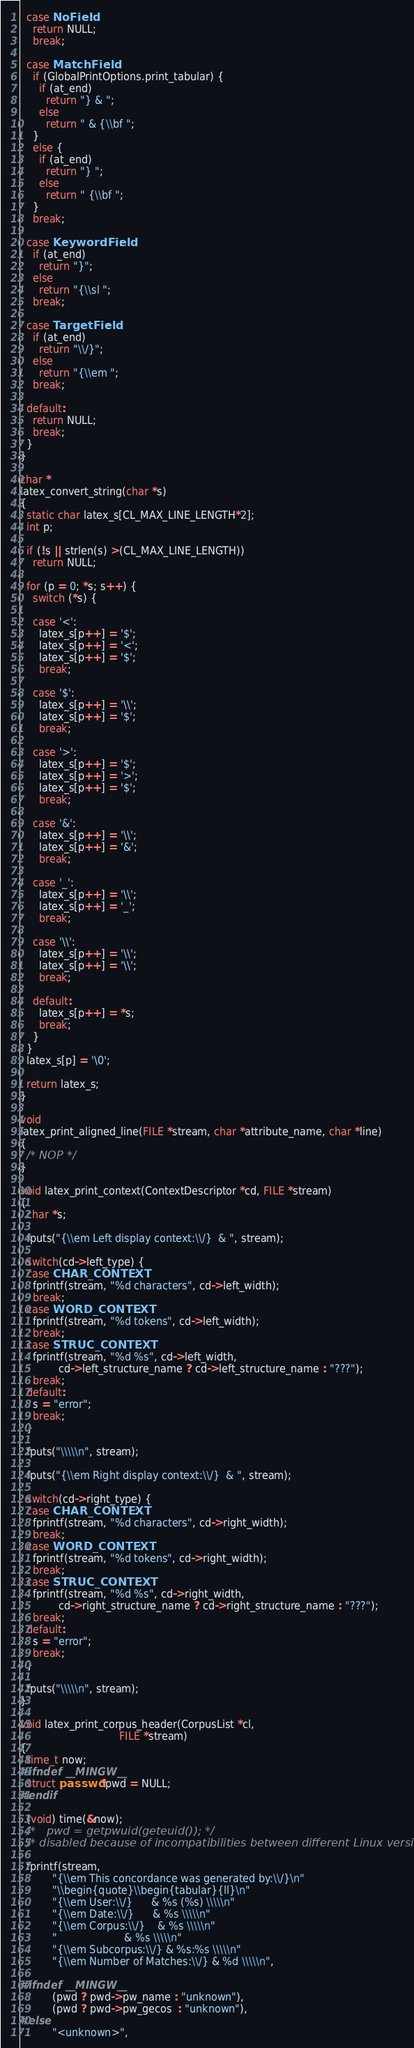<code> <loc_0><loc_0><loc_500><loc_500><_C_>
  case NoField:
    return NULL;
    break;

  case MatchField:
    if (GlobalPrintOptions.print_tabular) {
      if (at_end)
        return "} & ";
      else
        return " & {\\bf ";
    }
    else {
      if (at_end)
        return "} ";
      else
        return " {\\bf ";
    }
    break;

  case KeywordField:
    if (at_end)
      return "}";
    else
      return "{\\sl ";
    break;

  case TargetField:
    if (at_end)
      return "\\/}";
    else
      return "{\\em ";
    break;

  default:
    return NULL;
    break;
  }
}

char *
latex_convert_string(char *s)
{
  static char latex_s[CL_MAX_LINE_LENGTH*2];
  int p;

  if (!s || strlen(s) >(CL_MAX_LINE_LENGTH))
    return NULL;
  
  for (p = 0; *s; s++) {
    switch (*s) {

    case '<':
      latex_s[p++] = '$';
      latex_s[p++] = '<';
      latex_s[p++] = '$';
      break;

    case '$':
      latex_s[p++] = '\\';
      latex_s[p++] = '$';
      break;

    case '>':
      latex_s[p++] = '$';
      latex_s[p++] = '>';
      latex_s[p++] = '$';
      break;

    case '&':
      latex_s[p++] = '\\';
      latex_s[p++] = '&';
      break;

    case '_':
      latex_s[p++] = '\\';
      latex_s[p++] = '_';
      break;

    case '\\':
      latex_s[p++] = '\\';
      latex_s[p++] = '\\';
      break;

    default:
      latex_s[p++] = *s;
      break;
    }
  }
  latex_s[p] = '\0';

  return latex_s;
}

void
latex_print_aligned_line(FILE *stream, char *attribute_name, char *line)
{
  /* NOP */
}

void latex_print_context(ContextDescriptor *cd, FILE *stream)
{
  char *s;

  fputs("{\\em Left display context:\\/}  & ", stream);

  switch(cd->left_type) {
  case CHAR_CONTEXT:
    fprintf(stream, "%d characters", cd->left_width);
    break;
  case WORD_CONTEXT:
    fprintf(stream, "%d tokens", cd->left_width);
    break;
  case STRUC_CONTEXT:
    fprintf(stream, "%d %s", cd->left_width, 
            cd->left_structure_name ? cd->left_structure_name : "???");
    break;
  default:
    s = "error";
    break;
  }

  fputs("\\\\\n", stream);

  fputs("{\\em Right display context:\\/}  & ", stream);

  switch(cd->right_type) {
  case CHAR_CONTEXT:
    fprintf(stream, "%d characters", cd->right_width);
    break;
  case WORD_CONTEXT:
    fprintf(stream, "%d tokens", cd->right_width);
    break;
  case STRUC_CONTEXT:
    fprintf(stream, "%d %s", cd->right_width, 
            cd->right_structure_name ? cd->right_structure_name : "???");
    break;
  default:
    s = "error";
    break;
  }

  fputs("\\\\\n", stream);
}

void latex_print_corpus_header(CorpusList *cl, 
                               FILE *stream)
{
  time_t now;
#ifndef __MINGW__
  struct passwd *pwd = NULL;
#endif

  (void) time(&now);
  /*   pwd = getpwuid(geteuid()); */
  /* disabled because of incompatibilities between different Linux versions */

  fprintf(stream,
          "{\\em This concordance was generated by:\\/}\n"
          "\\begin{quote}\\begin{tabular}{ll}\n"
          "{\\em User:\\/}      & %s (%s) \\\\\n"
          "{\\em Date:\\/}      & %s \\\\\n"
          "{\\em Corpus:\\/}    & %s \\\\\n"
          "                     & %s \\\\\n"
          "{\\em Subcorpus:\\/} & %s:%s \\\\\n"
          "{\\em Number of Matches:\\/} & %d \\\\\n",

#ifndef __MINGW__
          (pwd ? pwd->pw_name : "unknown"),
          (pwd ? pwd->pw_gecos  : "unknown"),
#else
          "<unknown>",</code> 